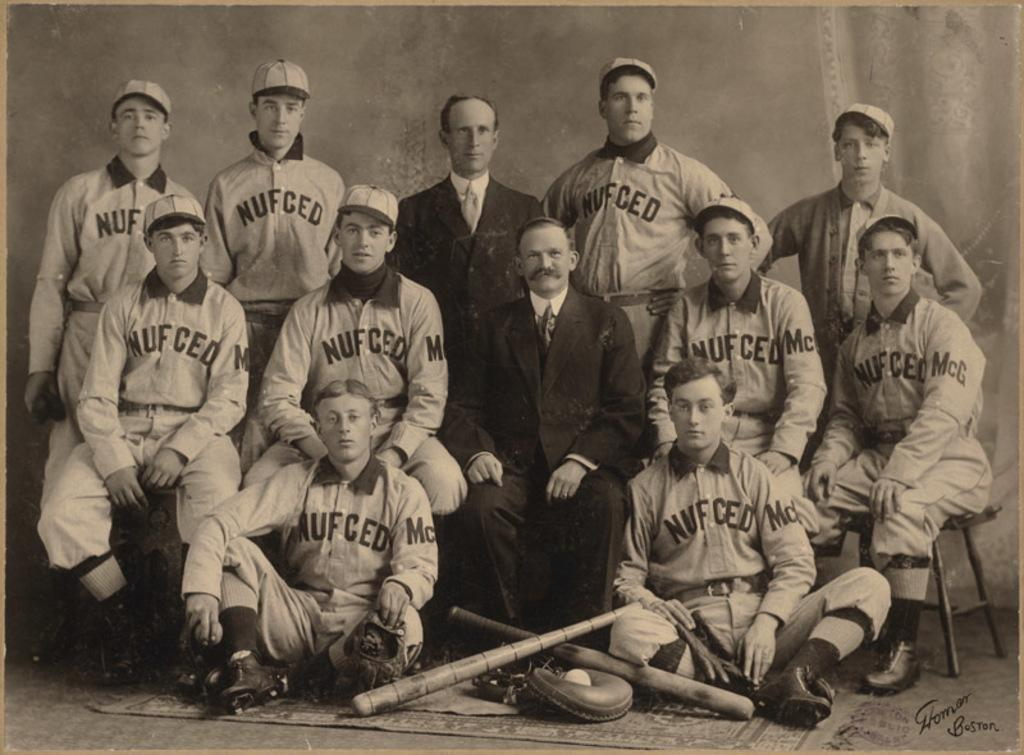<image>
Render a clear and concise summary of the photo. Team photo with the word "NUFCED" on the front. 